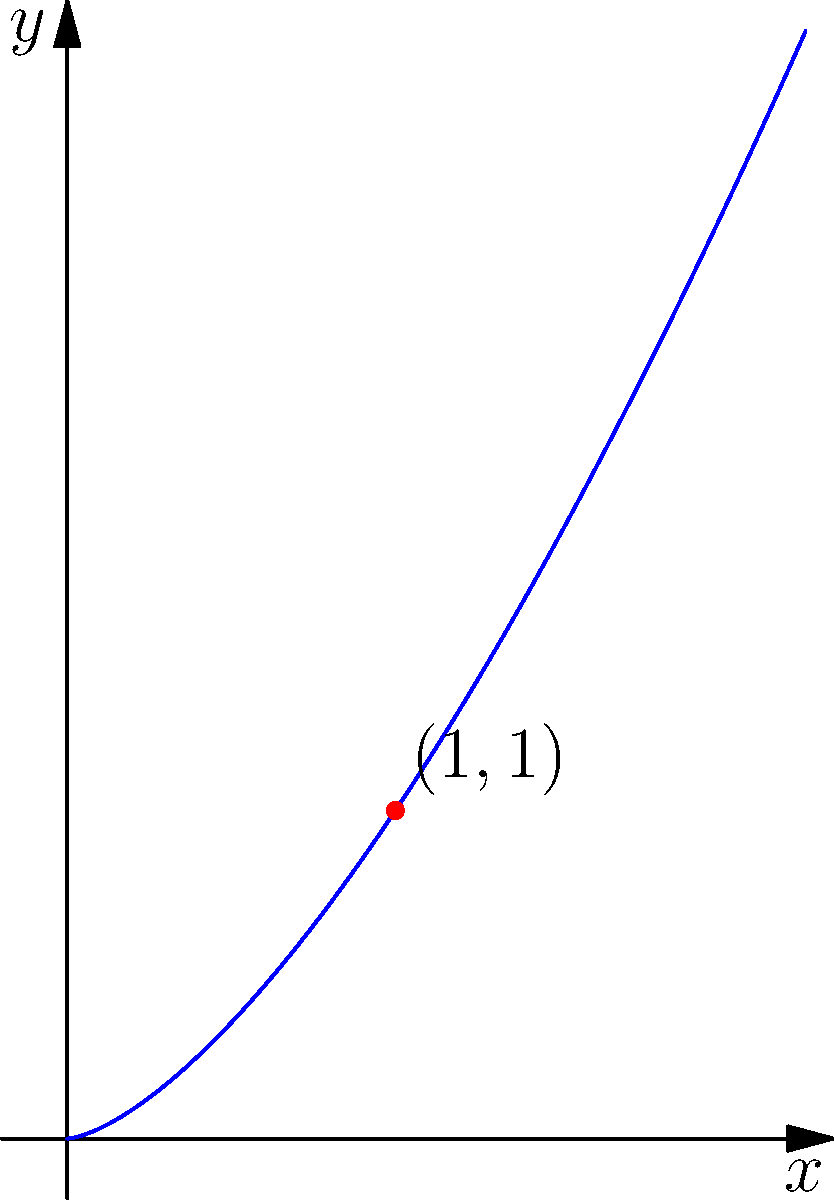A particle moves along the curve given by $y = x^{3/2}$. At the point (1, 1), find the instantaneous rate of change of the y-coordinate with respect to time if the x-coordinate is changing at a rate of 4 units per second. To solve this problem, we'll follow these steps:

1) First, we need to find $\frac{dy}{dx}$ using the chain rule:
   $y = x^{3/2}$
   $\frac{dy}{dx} = \frac{3}{2}x^{1/2}$

2) At the point (1, 1), $x = 1$, so:
   $\frac{dy}{dx}|_{x=1} = \frac{3}{2}(1)^{1/2} = \frac{3}{2}$

3) We're given that $\frac{dx}{dt} = 4$ at this point.

4) Now, we can use the chain rule to find $\frac{dy}{dt}$:
   $\frac{dy}{dt} = \frac{dy}{dx} \cdot \frac{dx}{dt}$

5) Substituting the values we know:
   $\frac{dy}{dt} = \frac{3}{2} \cdot 4 = 6$

Therefore, at the point (1, 1), the y-coordinate is changing at a rate of 6 units per second.
Answer: $6$ units per second 